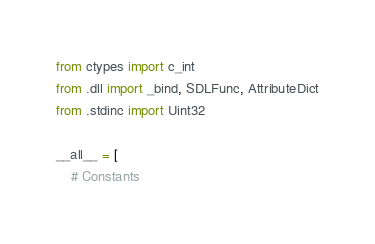<code> <loc_0><loc_0><loc_500><loc_500><_Python_>from ctypes import c_int
from .dll import _bind, SDLFunc, AttributeDict
from .stdinc import Uint32

__all__ = [
    # Constants</code> 